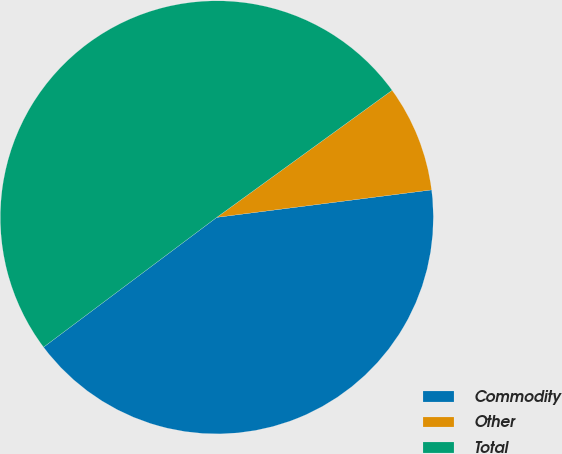Convert chart to OTSL. <chart><loc_0><loc_0><loc_500><loc_500><pie_chart><fcel>Commodity<fcel>Other<fcel>Total<nl><fcel>41.79%<fcel>7.96%<fcel>50.25%<nl></chart> 